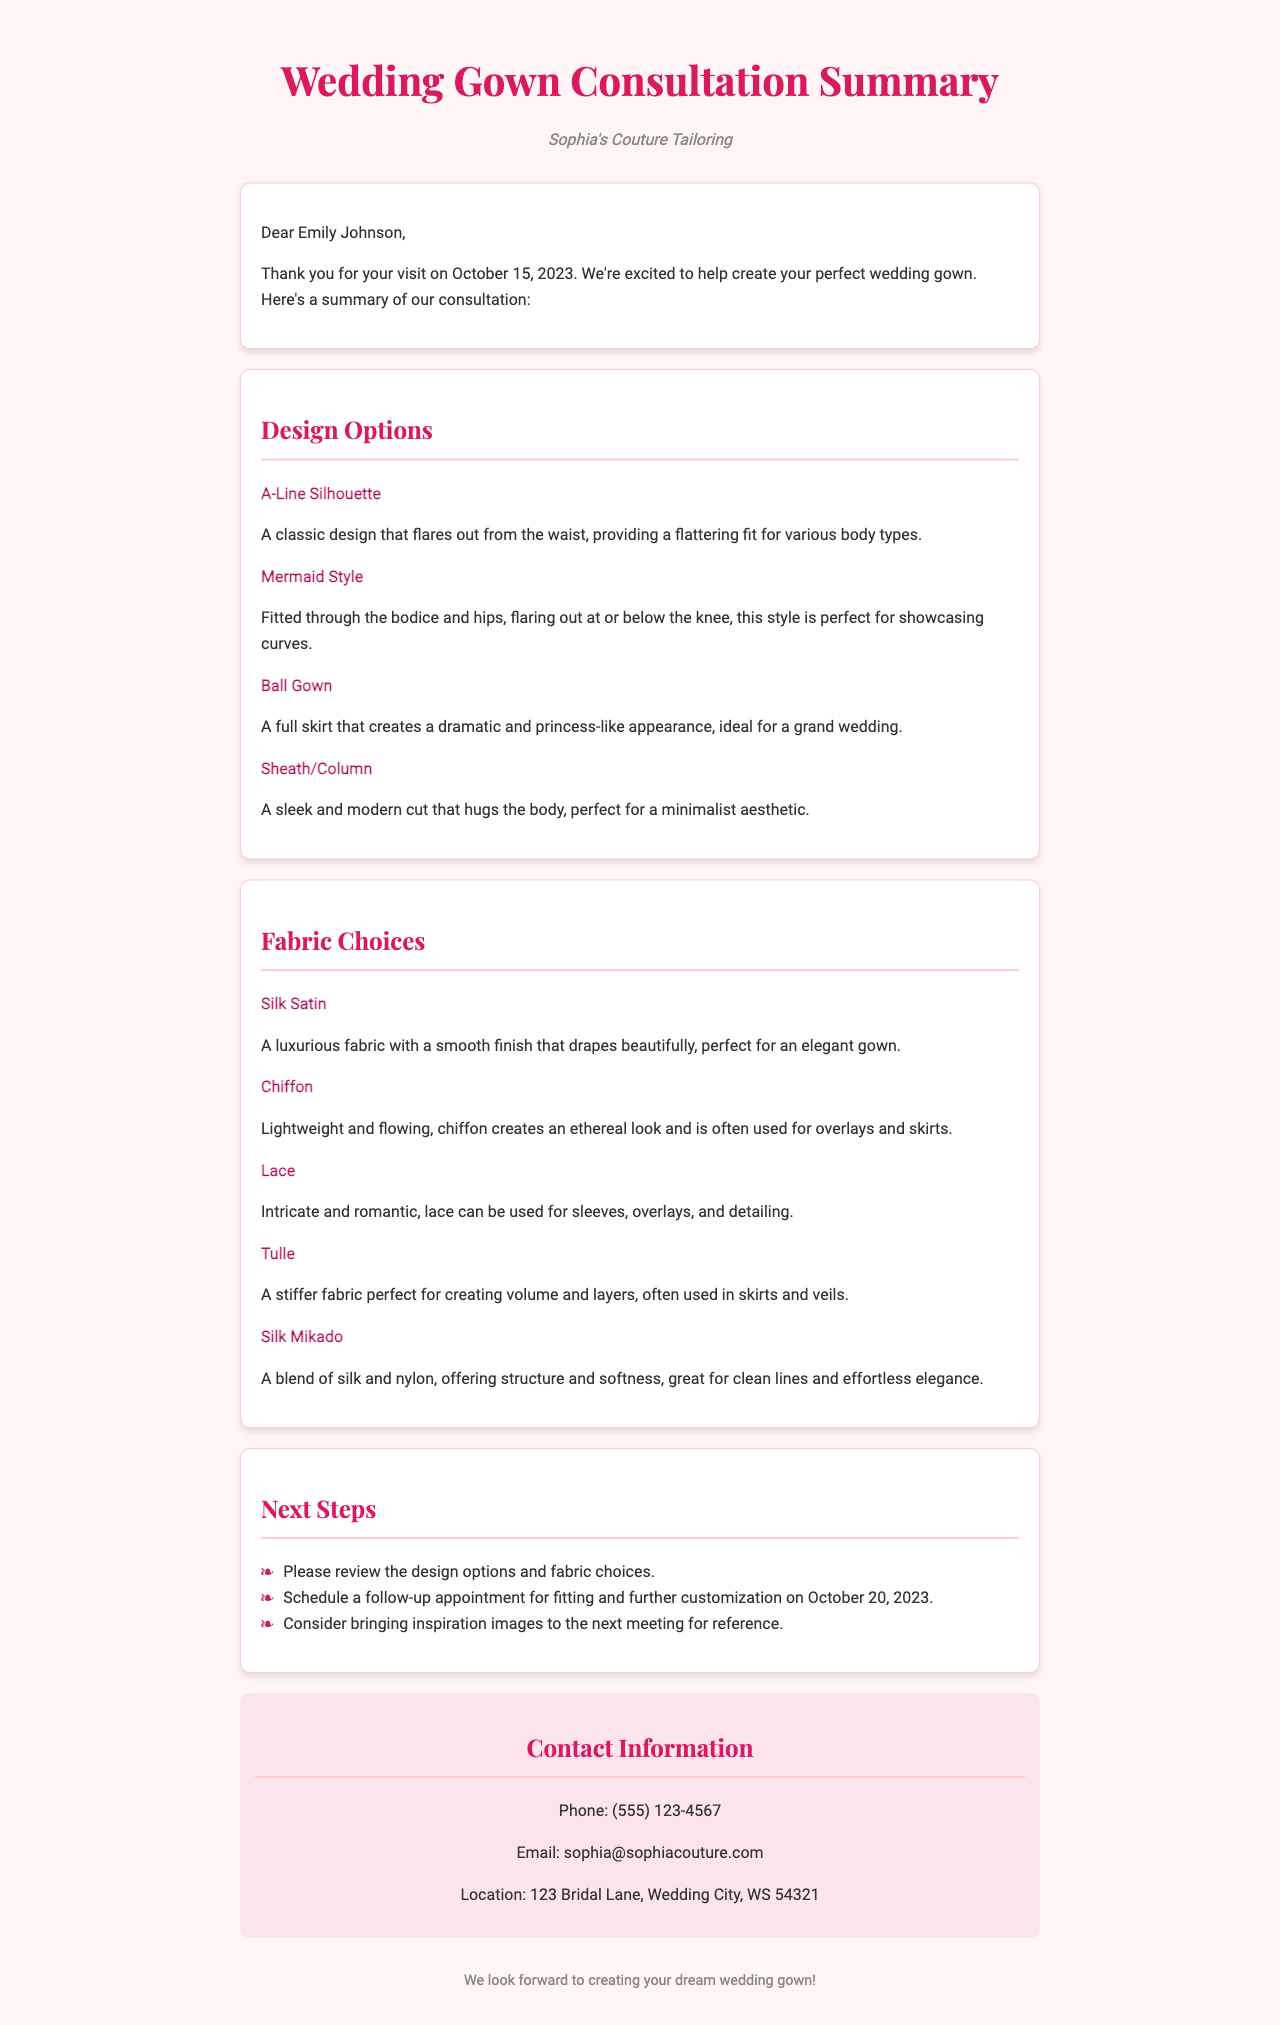What is the name of the tailor? The tailor's name is mentioned in the header of the document as Sophia's Couture Tailoring.
Answer: Sophia's Couture Tailoring What date was the consultation held? The date of the consultation is specified in the greeting section of the document as October 15, 2023.
Answer: October 15, 2023 Which design option provides a flattering fit for various body types? The design option that provides a flattering fit is described as the A-Line Silhouette in the design options section.
Answer: A-Line Silhouette What type of fabric is described as lightweight and flowing? The fabric described as lightweight and flowing is Chiffon, as noted in the fabric choices section.
Answer: Chiffon What are the next steps mentioned for the client? The next steps include reviewing the design options, scheduling a follow-up appointment, and bringing inspiration images.
Answer: Review design options, schedule follow-up, bring inspiration images What is the phone number provided for contact? The contact information section lists the phone number to reach the tailor, which is specifically mentioned.
Answer: (555) 123-4567 Which design style is best for showcasing curves? The document specifies that the Mermaid Style is perfect for showcasing curves.
Answer: Mermaid Style What is the primary color theme used in the document? The color theme is primarily indicated by the use of colors in headings and highlights throughout the document.
Answer: Pink 